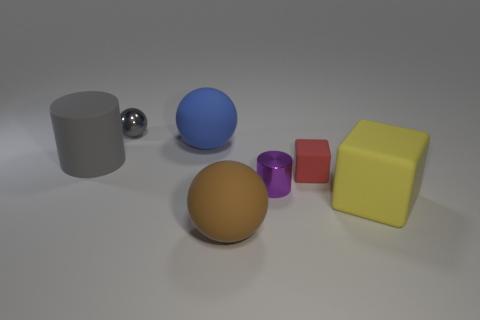Subtract all blue balls. How many balls are left? 2 Add 2 small brown blocks. How many objects exist? 9 Subtract all gray spheres. How many spheres are left? 2 Subtract all cubes. How many objects are left? 5 Add 5 red things. How many red things are left? 6 Add 7 cylinders. How many cylinders exist? 9 Subtract 0 gray blocks. How many objects are left? 7 Subtract all cyan cylinders. Subtract all blue spheres. How many cylinders are left? 2 Subtract all cyan balls. How many yellow cubes are left? 1 Subtract all brown matte cylinders. Subtract all small rubber things. How many objects are left? 6 